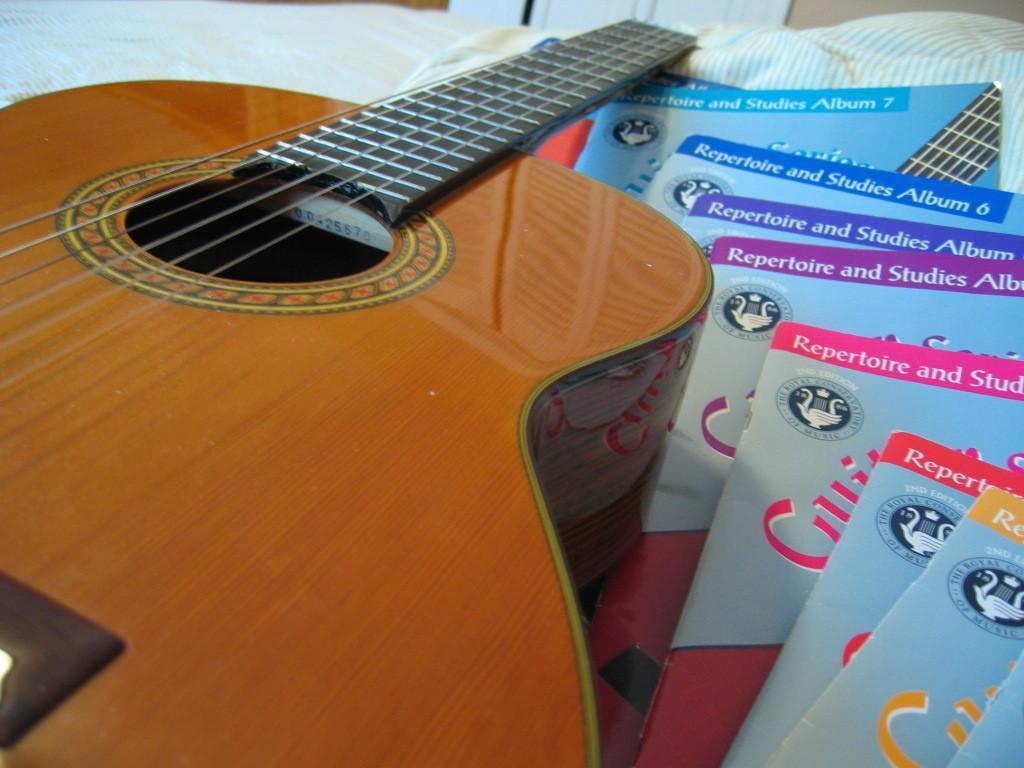Can you describe this image briefly? in the picture we can see a guitar along with some books present beside the guitar. 